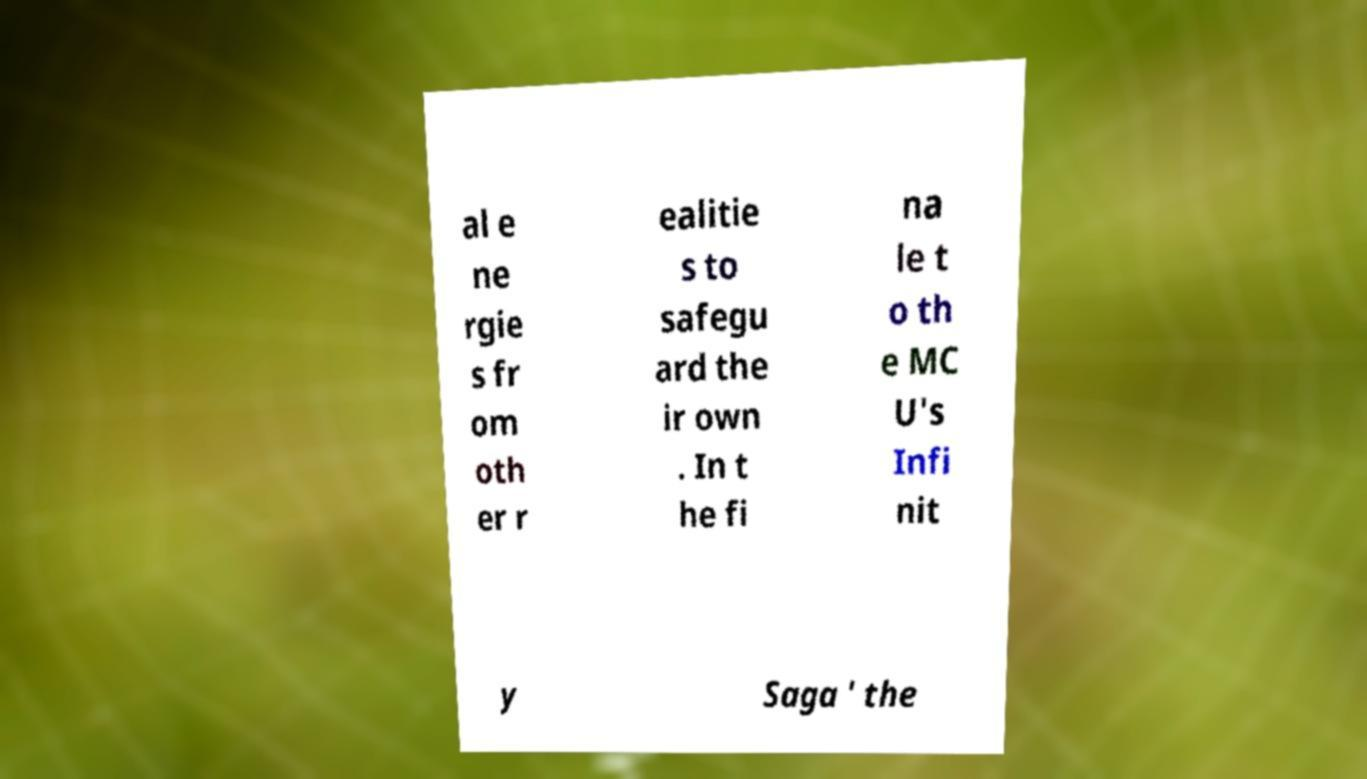Can you read and provide the text displayed in the image?This photo seems to have some interesting text. Can you extract and type it out for me? al e ne rgie s fr om oth er r ealitie s to safegu ard the ir own . In t he fi na le t o th e MC U's Infi nit y Saga ' the 